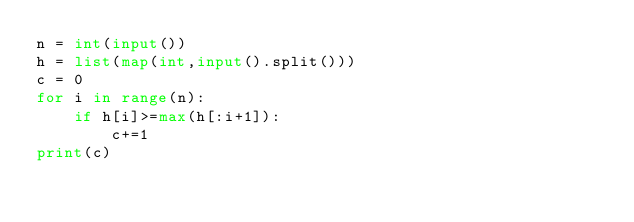Convert code to text. <code><loc_0><loc_0><loc_500><loc_500><_Python_>n = int(input())
h = list(map(int,input().split()))
c = 0
for i in range(n):
    if h[i]>=max(h[:i+1]):
        c+=1
print(c)</code> 